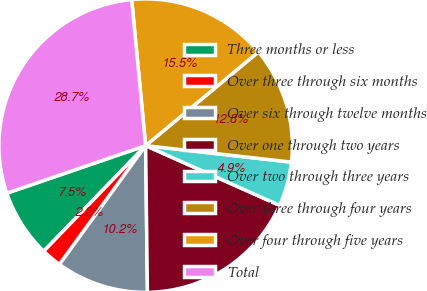Convert chart. <chart><loc_0><loc_0><loc_500><loc_500><pie_chart><fcel>Three months or less<fcel>Over three through six months<fcel>Over six through twelve months<fcel>Over one through two years<fcel>Over two through three years<fcel>Over three through four years<fcel>Over four through five years<fcel>Total<nl><fcel>7.53%<fcel>2.23%<fcel>10.18%<fcel>18.13%<fcel>4.88%<fcel>12.83%<fcel>15.48%<fcel>28.73%<nl></chart> 